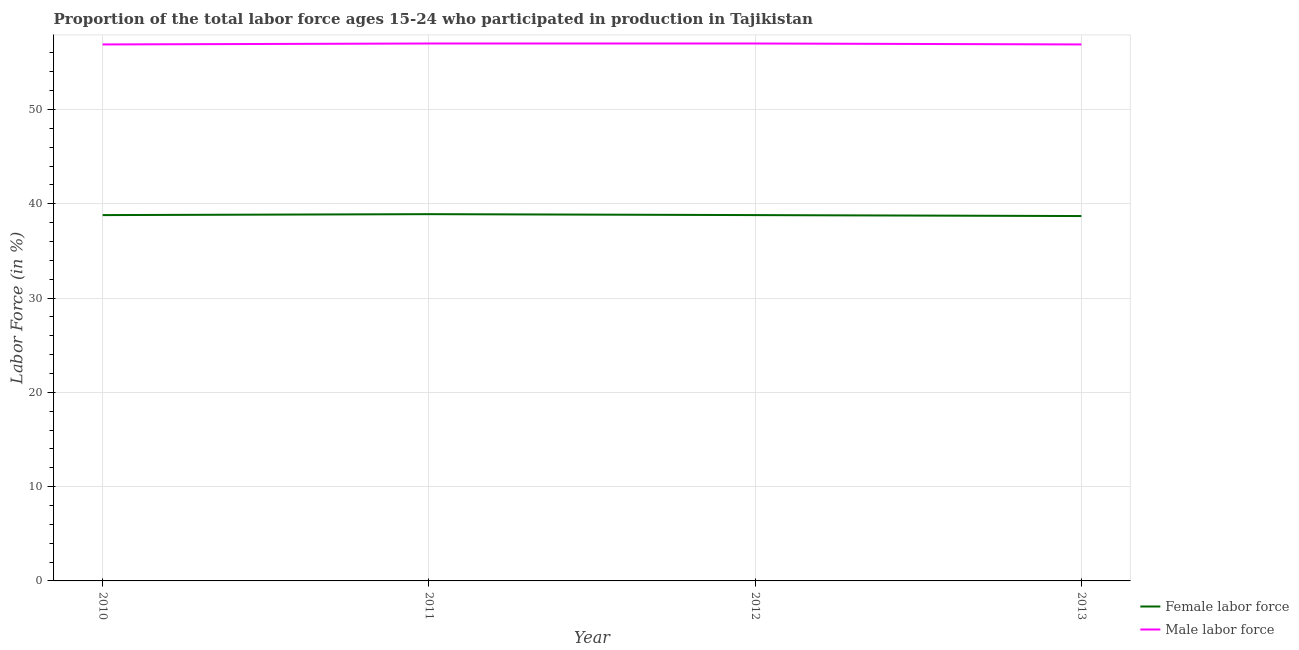How many different coloured lines are there?
Your answer should be very brief. 2. Does the line corresponding to percentage of male labour force intersect with the line corresponding to percentage of female labor force?
Provide a succinct answer. No. Is the number of lines equal to the number of legend labels?
Offer a very short reply. Yes. What is the percentage of female labor force in 2010?
Ensure brevity in your answer.  38.8. Across all years, what is the minimum percentage of male labour force?
Your answer should be very brief. 56.9. In which year was the percentage of male labour force maximum?
Offer a very short reply. 2011. In which year was the percentage of female labor force minimum?
Give a very brief answer. 2013. What is the total percentage of female labor force in the graph?
Offer a very short reply. 155.2. What is the difference between the percentage of male labour force in 2011 and that in 2013?
Ensure brevity in your answer.  0.1. What is the difference between the percentage of female labor force in 2011 and the percentage of male labour force in 2012?
Offer a terse response. -18.1. What is the average percentage of female labor force per year?
Make the answer very short. 38.8. In the year 2013, what is the difference between the percentage of female labor force and percentage of male labour force?
Offer a very short reply. -18.2. What is the ratio of the percentage of male labour force in 2012 to that in 2013?
Keep it short and to the point. 1. What is the difference between the highest and the second highest percentage of female labor force?
Ensure brevity in your answer.  0.1. What is the difference between the highest and the lowest percentage of female labor force?
Provide a short and direct response. 0.2. In how many years, is the percentage of female labor force greater than the average percentage of female labor force taken over all years?
Make the answer very short. 1. Is the sum of the percentage of male labour force in 2010 and 2011 greater than the maximum percentage of female labor force across all years?
Provide a succinct answer. Yes. Is the percentage of male labour force strictly greater than the percentage of female labor force over the years?
Provide a succinct answer. Yes. How many lines are there?
Provide a succinct answer. 2. How many years are there in the graph?
Offer a very short reply. 4. What is the difference between two consecutive major ticks on the Y-axis?
Your answer should be compact. 10. Are the values on the major ticks of Y-axis written in scientific E-notation?
Provide a short and direct response. No. Does the graph contain any zero values?
Offer a terse response. No. Does the graph contain grids?
Provide a short and direct response. Yes. How many legend labels are there?
Your answer should be very brief. 2. How are the legend labels stacked?
Your answer should be very brief. Vertical. What is the title of the graph?
Your answer should be very brief. Proportion of the total labor force ages 15-24 who participated in production in Tajikistan. Does "Residents" appear as one of the legend labels in the graph?
Your answer should be very brief. No. What is the label or title of the X-axis?
Your answer should be compact. Year. What is the label or title of the Y-axis?
Ensure brevity in your answer.  Labor Force (in %). What is the Labor Force (in %) in Female labor force in 2010?
Offer a terse response. 38.8. What is the Labor Force (in %) in Male labor force in 2010?
Provide a succinct answer. 56.9. What is the Labor Force (in %) in Female labor force in 2011?
Make the answer very short. 38.9. What is the Labor Force (in %) of Female labor force in 2012?
Offer a terse response. 38.8. What is the Labor Force (in %) in Male labor force in 2012?
Make the answer very short. 57. What is the Labor Force (in %) in Female labor force in 2013?
Offer a very short reply. 38.7. What is the Labor Force (in %) in Male labor force in 2013?
Offer a very short reply. 56.9. Across all years, what is the maximum Labor Force (in %) in Female labor force?
Make the answer very short. 38.9. Across all years, what is the minimum Labor Force (in %) in Female labor force?
Offer a very short reply. 38.7. Across all years, what is the minimum Labor Force (in %) in Male labor force?
Offer a very short reply. 56.9. What is the total Labor Force (in %) in Female labor force in the graph?
Your answer should be compact. 155.2. What is the total Labor Force (in %) in Male labor force in the graph?
Offer a terse response. 227.8. What is the difference between the Labor Force (in %) in Female labor force in 2010 and that in 2011?
Offer a very short reply. -0.1. What is the difference between the Labor Force (in %) of Female labor force in 2010 and that in 2012?
Provide a short and direct response. 0. What is the difference between the Labor Force (in %) of Male labor force in 2010 and that in 2012?
Your response must be concise. -0.1. What is the difference between the Labor Force (in %) of Female labor force in 2011 and that in 2012?
Ensure brevity in your answer.  0.1. What is the difference between the Labor Force (in %) in Female labor force in 2011 and that in 2013?
Ensure brevity in your answer.  0.2. What is the difference between the Labor Force (in %) in Male labor force in 2011 and that in 2013?
Keep it short and to the point. 0.1. What is the difference between the Labor Force (in %) of Female labor force in 2010 and the Labor Force (in %) of Male labor force in 2011?
Provide a short and direct response. -18.2. What is the difference between the Labor Force (in %) of Female labor force in 2010 and the Labor Force (in %) of Male labor force in 2012?
Give a very brief answer. -18.2. What is the difference between the Labor Force (in %) in Female labor force in 2010 and the Labor Force (in %) in Male labor force in 2013?
Give a very brief answer. -18.1. What is the difference between the Labor Force (in %) of Female labor force in 2011 and the Labor Force (in %) of Male labor force in 2012?
Give a very brief answer. -18.1. What is the difference between the Labor Force (in %) of Female labor force in 2011 and the Labor Force (in %) of Male labor force in 2013?
Provide a succinct answer. -18. What is the difference between the Labor Force (in %) in Female labor force in 2012 and the Labor Force (in %) in Male labor force in 2013?
Make the answer very short. -18.1. What is the average Labor Force (in %) in Female labor force per year?
Give a very brief answer. 38.8. What is the average Labor Force (in %) of Male labor force per year?
Your answer should be very brief. 56.95. In the year 2010, what is the difference between the Labor Force (in %) of Female labor force and Labor Force (in %) of Male labor force?
Your answer should be very brief. -18.1. In the year 2011, what is the difference between the Labor Force (in %) of Female labor force and Labor Force (in %) of Male labor force?
Your response must be concise. -18.1. In the year 2012, what is the difference between the Labor Force (in %) in Female labor force and Labor Force (in %) in Male labor force?
Ensure brevity in your answer.  -18.2. In the year 2013, what is the difference between the Labor Force (in %) of Female labor force and Labor Force (in %) of Male labor force?
Your answer should be compact. -18.2. What is the ratio of the Labor Force (in %) in Female labor force in 2010 to that in 2011?
Offer a very short reply. 1. What is the ratio of the Labor Force (in %) in Female labor force in 2010 to that in 2013?
Give a very brief answer. 1. What is the ratio of the Labor Force (in %) of Male labor force in 2011 to that in 2012?
Keep it short and to the point. 1. What is the ratio of the Labor Force (in %) in Female labor force in 2011 to that in 2013?
Offer a very short reply. 1.01. What is the ratio of the Labor Force (in %) of Female labor force in 2012 to that in 2013?
Ensure brevity in your answer.  1. 